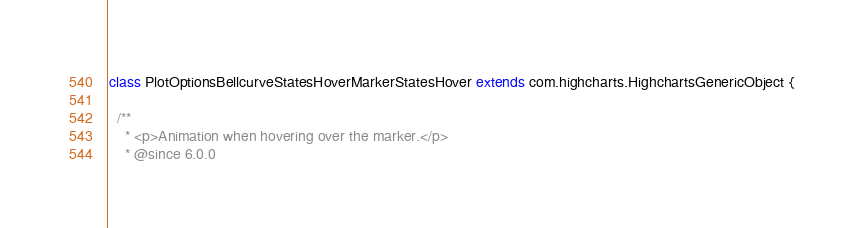Convert code to text. <code><loc_0><loc_0><loc_500><loc_500><_Scala_>class PlotOptionsBellcurveStatesHoverMarkerStatesHover extends com.highcharts.HighchartsGenericObject {

  /**
    * <p>Animation when hovering over the marker.</p>
    * @since 6.0.0</code> 